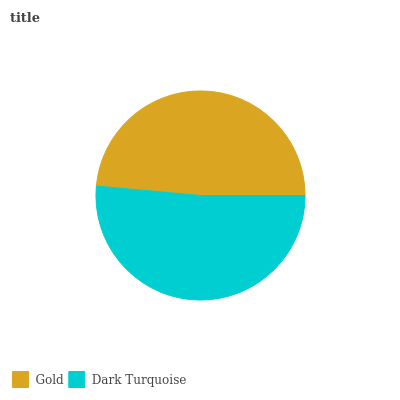Is Gold the minimum?
Answer yes or no. Yes. Is Dark Turquoise the maximum?
Answer yes or no. Yes. Is Dark Turquoise the minimum?
Answer yes or no. No. Is Dark Turquoise greater than Gold?
Answer yes or no. Yes. Is Gold less than Dark Turquoise?
Answer yes or no. Yes. Is Gold greater than Dark Turquoise?
Answer yes or no. No. Is Dark Turquoise less than Gold?
Answer yes or no. No. Is Dark Turquoise the high median?
Answer yes or no. Yes. Is Gold the low median?
Answer yes or no. Yes. Is Gold the high median?
Answer yes or no. No. Is Dark Turquoise the low median?
Answer yes or no. No. 